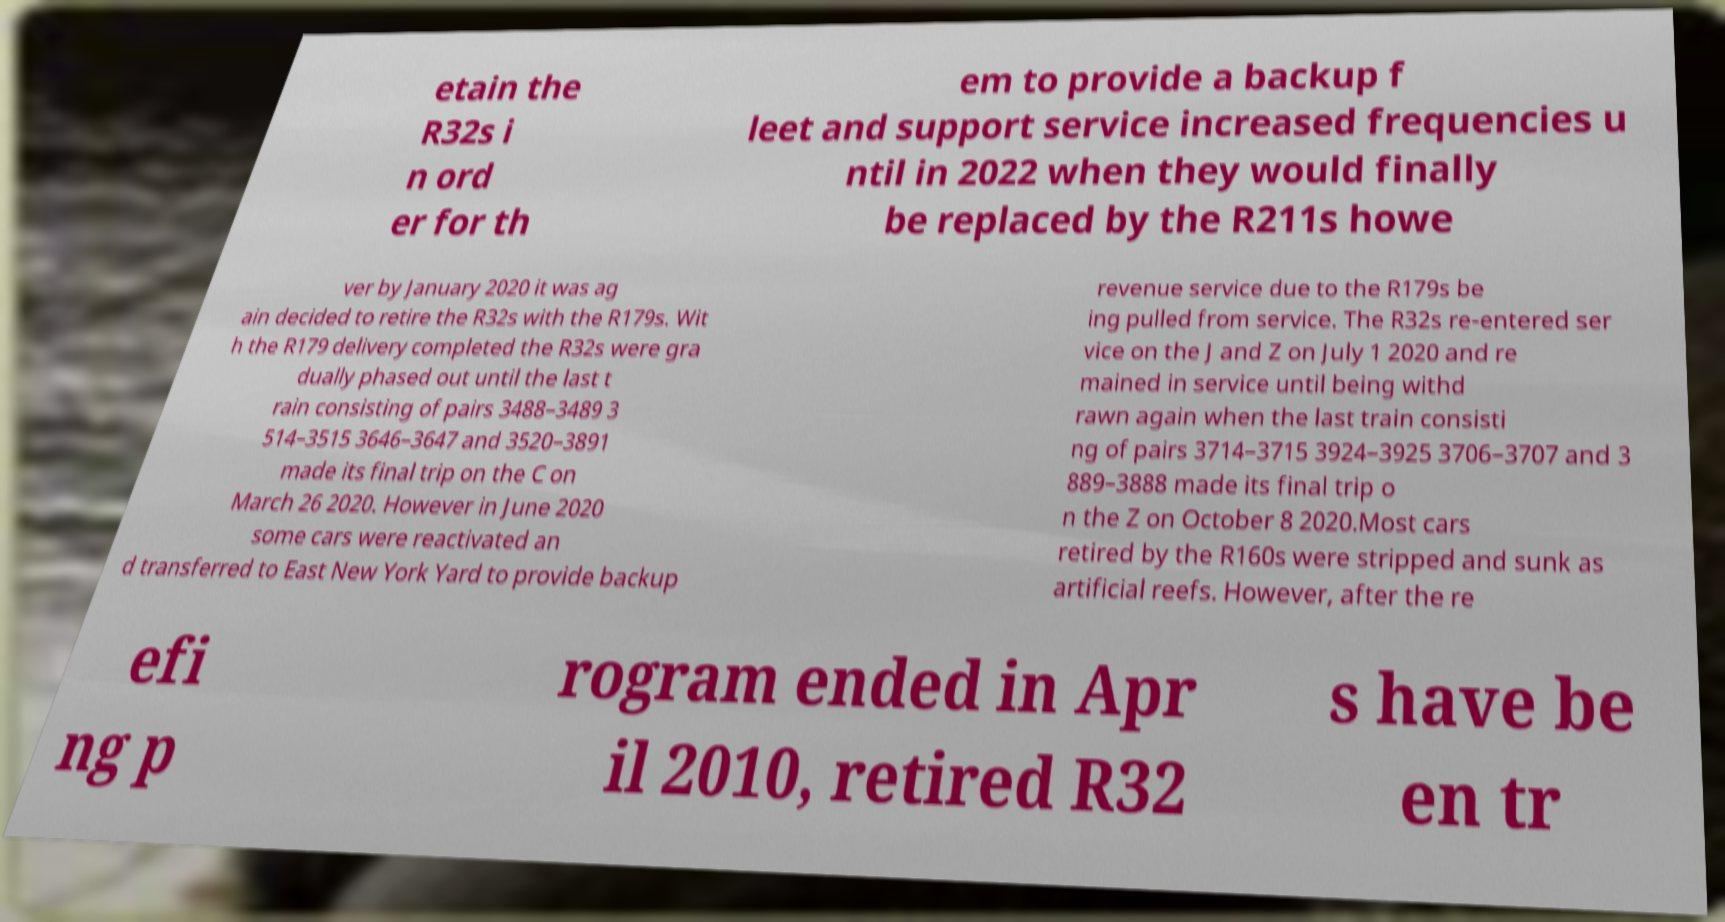Please identify and transcribe the text found in this image. etain the R32s i n ord er for th em to provide a backup f leet and support service increased frequencies u ntil in 2022 when they would finally be replaced by the R211s howe ver by January 2020 it was ag ain decided to retire the R32s with the R179s. Wit h the R179 delivery completed the R32s were gra dually phased out until the last t rain consisting of pairs 3488–3489 3 514–3515 3646–3647 and 3520–3891 made its final trip on the C on March 26 2020. However in June 2020 some cars were reactivated an d transferred to East New York Yard to provide backup revenue service due to the R179s be ing pulled from service. The R32s re-entered ser vice on the J and Z on July 1 2020 and re mained in service until being withd rawn again when the last train consisti ng of pairs 3714–3715 3924–3925 3706–3707 and 3 889–3888 made its final trip o n the Z on October 8 2020.Most cars retired by the R160s were stripped and sunk as artificial reefs. However, after the re efi ng p rogram ended in Apr il 2010, retired R32 s have be en tr 